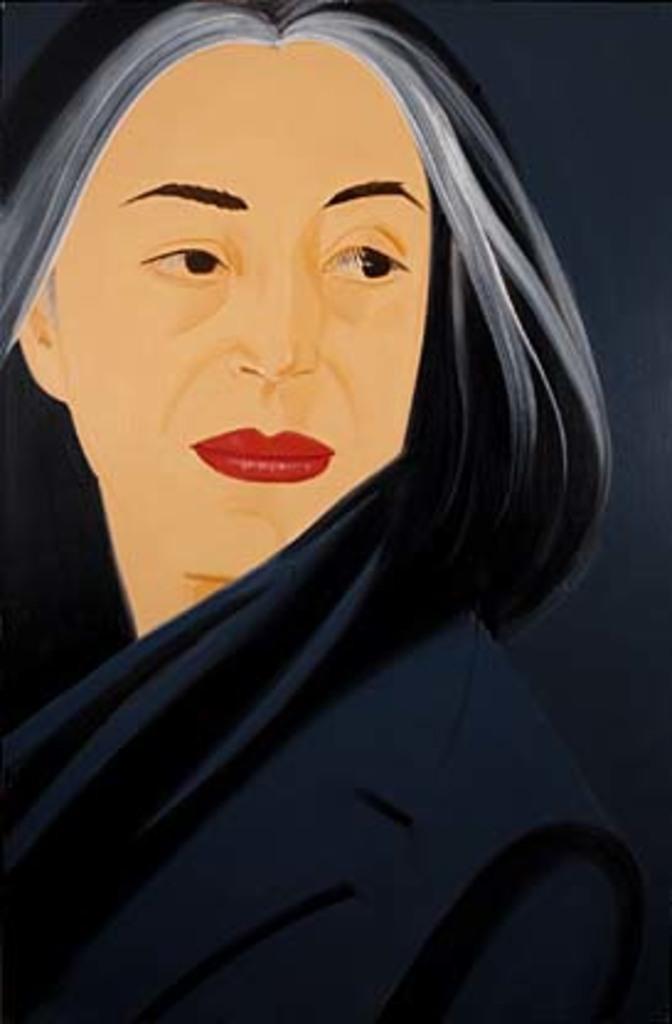Could you give a brief overview of what you see in this image? By seeing image we can say it is a painting of a lady. 